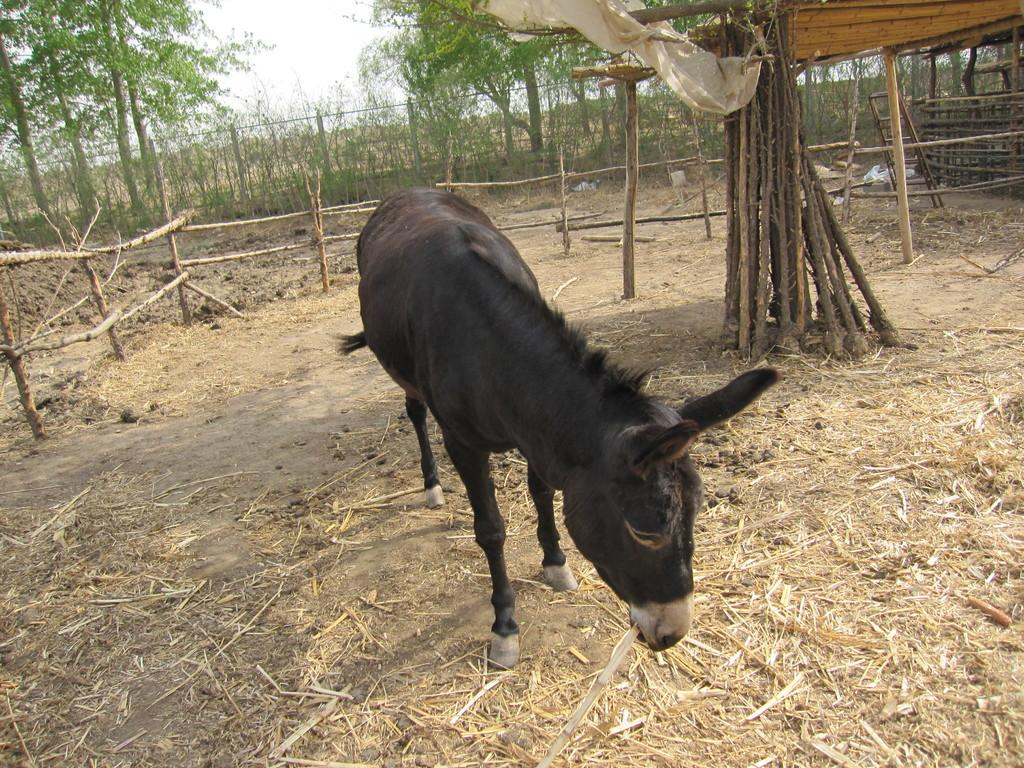What animal is present in the image? There is a donkey in the image. What is the donkey doing in the image? The donkey is eating grass in the image. What type of vegetation can be seen in the image? There are trees in the image, specifically bamboos. What type of pancake is being served on the land in the image? There is no pancake or land present in the image; it features a donkey eating grass near bamboo trees. How deep is the hole in the image? There is no hole present in the image. 